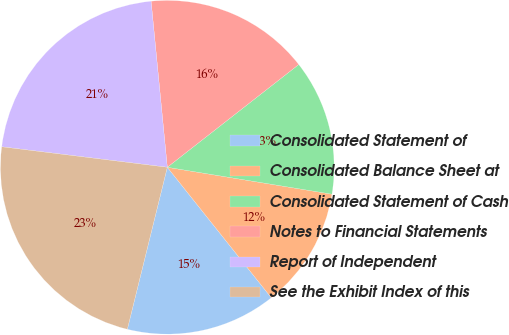<chart> <loc_0><loc_0><loc_500><loc_500><pie_chart><fcel>Consolidated Statement of<fcel>Consolidated Balance Sheet at<fcel>Consolidated Statement of Cash<fcel>Notes to Financial Statements<fcel>Report of Independent<fcel>See the Exhibit Index of this<nl><fcel>14.56%<fcel>11.71%<fcel>13.14%<fcel>15.99%<fcel>21.49%<fcel>23.11%<nl></chart> 